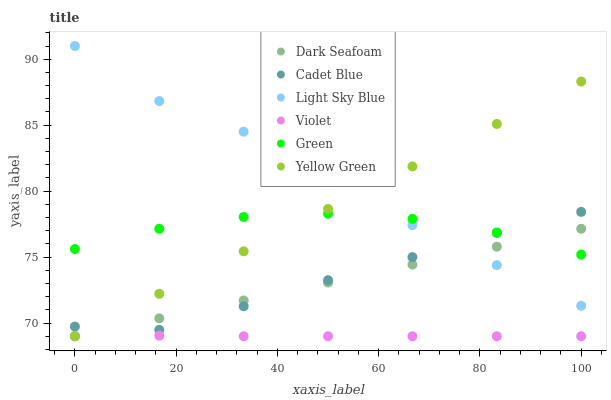Does Violet have the minimum area under the curve?
Answer yes or no. Yes. Does Light Sky Blue have the maximum area under the curve?
Answer yes or no. Yes. Does Yellow Green have the minimum area under the curve?
Answer yes or no. No. Does Yellow Green have the maximum area under the curve?
Answer yes or no. No. Is Dark Seafoam the smoothest?
Answer yes or no. Yes. Is Light Sky Blue the roughest?
Answer yes or no. Yes. Is Yellow Green the smoothest?
Answer yes or no. No. Is Yellow Green the roughest?
Answer yes or no. No. Does Yellow Green have the lowest value?
Answer yes or no. Yes. Does Light Sky Blue have the lowest value?
Answer yes or no. No. Does Light Sky Blue have the highest value?
Answer yes or no. Yes. Does Yellow Green have the highest value?
Answer yes or no. No. Is Violet less than Green?
Answer yes or no. Yes. Is Cadet Blue greater than Violet?
Answer yes or no. Yes. Does Light Sky Blue intersect Green?
Answer yes or no. Yes. Is Light Sky Blue less than Green?
Answer yes or no. No. Is Light Sky Blue greater than Green?
Answer yes or no. No. Does Violet intersect Green?
Answer yes or no. No. 